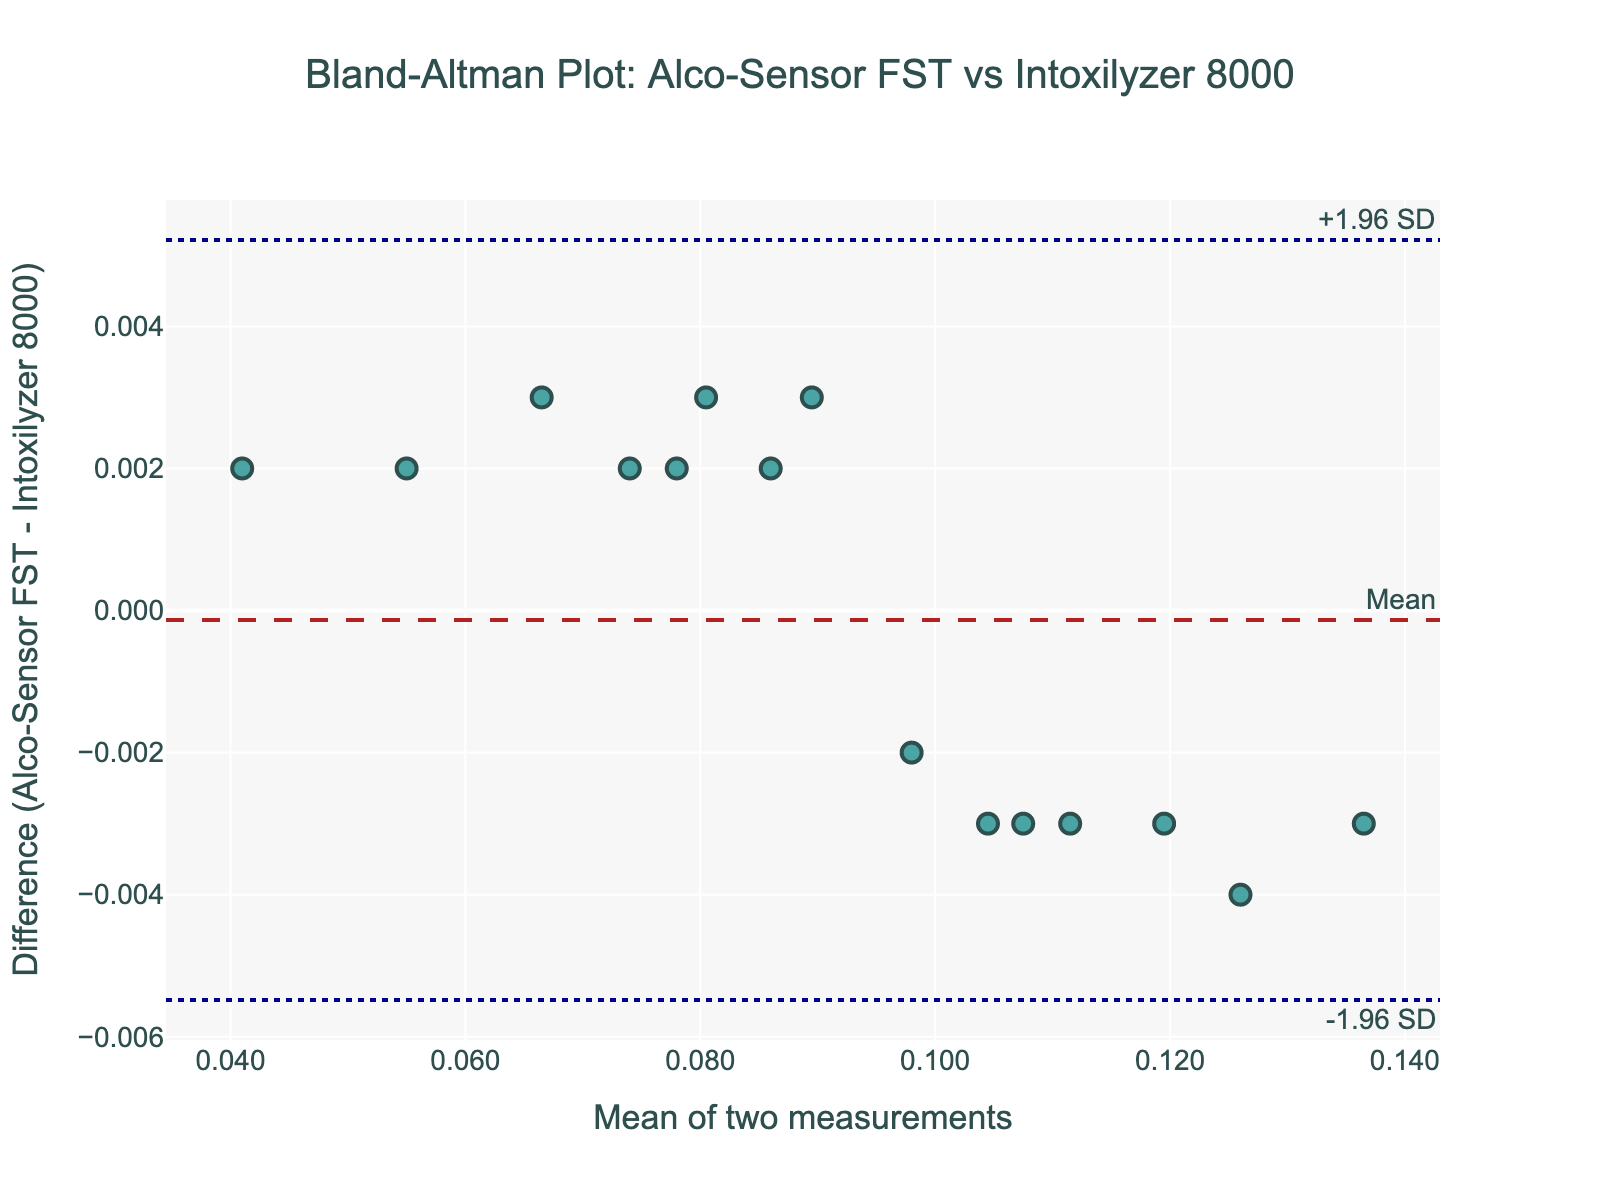How many data points are plotted in the Bland-Altman plot? Count the number of markers in the plot. Each marker represents a data point.
Answer: 15 What is the mean difference between the two devices? Identify the horizontal dashed line labeled "Mean" on the plot, which represents the mean difference.
Answer: Close to 0.001 What is the range of the differences between the two readings? Observe the vertical axis titled "Difference (Alco-Sensor FST - Intoxilyzer 8000)" and find the maximum and minimum values of the markers.
Answer: -0.005 to 0.005 Which device tends to give higher readings on average? If the mean difference (dashed line) is above 0, the Alco-Sensor FST gives higher readings on average. If below 0, the Intoxilyzer 8000 gives higher readings.
Answer: Intoxilyzer 8000 slightly higher Are there any differences that fall outside +/- 1.96 SD? Examine if any markers fall outside the upper and lower dotted lines labeled "+1.96 SD" and "-1.96 SD."
Answer: No What does the upper limit of agreement (+1.96 SD) represent approximately in the plot? Locate the upper dotted line labeled "+1.96 SD" and read its y-value.
Answer: About 0.003 What does the lower limit of agreement (-1.96 SD) represent approximately in the plot? Locate the lower dotted line labeled "-1.96 SD" and read its y-value.
Answer: About -0.003 How does the mean of the two measurements affect the differences in readings? Observe any pattern or trend in the scatter plot, such as whether differences increase or decrease with the mean values.
Answer: No clear trend Is there a visible trend that suggests systematic bias between the two devices? Look at the distribution of markers and the mean difference to see if the differences consistently deviate in one direction.
Answer: No systematic bias Which values indicate the most significant discrepancies between the devices? Identify the markers farthest from the horizontal dashed line representing the mean difference.
Answer: Values near upper and lower limits of agreement 